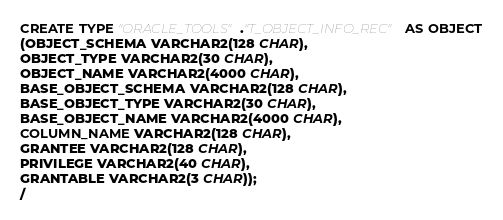<code> <loc_0><loc_0><loc_500><loc_500><_SQL_>CREATE TYPE "ORACLE_TOOLS"."T_OBJECT_INFO_REC" AS OBJECT
(OBJECT_SCHEMA VARCHAR2(128 CHAR),
OBJECT_TYPE VARCHAR2(30 CHAR),
OBJECT_NAME VARCHAR2(4000 CHAR),
BASE_OBJECT_SCHEMA VARCHAR2(128 CHAR),
BASE_OBJECT_TYPE VARCHAR2(30 CHAR),
BASE_OBJECT_NAME VARCHAR2(4000 CHAR),
COLUMN_NAME VARCHAR2(128 CHAR),
GRANTEE VARCHAR2(128 CHAR),
PRIVILEGE VARCHAR2(40 CHAR),
GRANTABLE VARCHAR2(3 CHAR));
/

</code> 